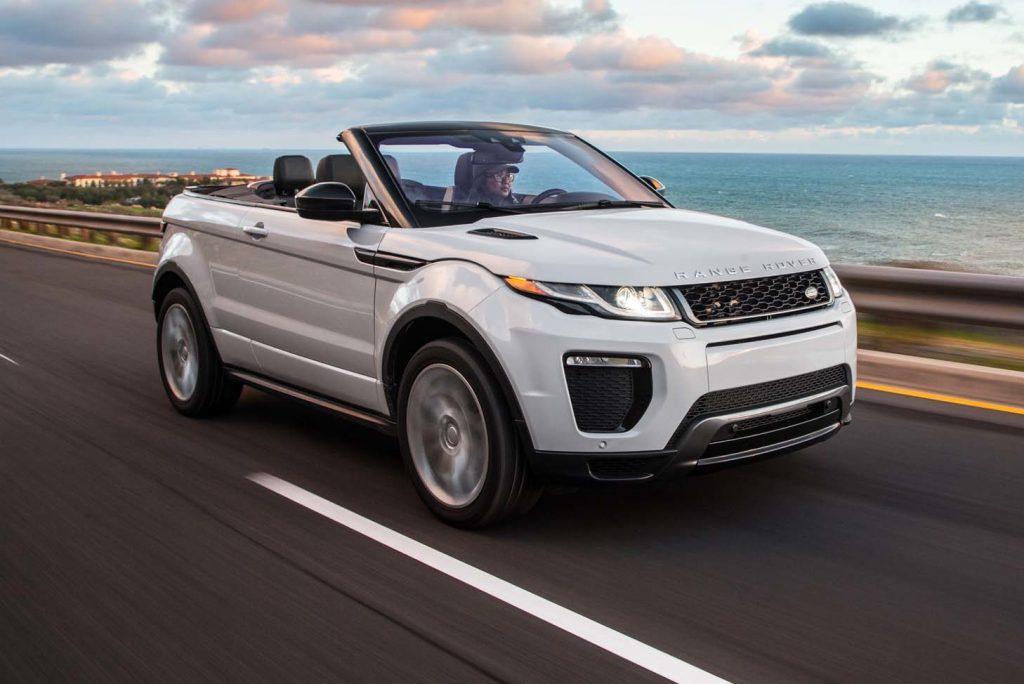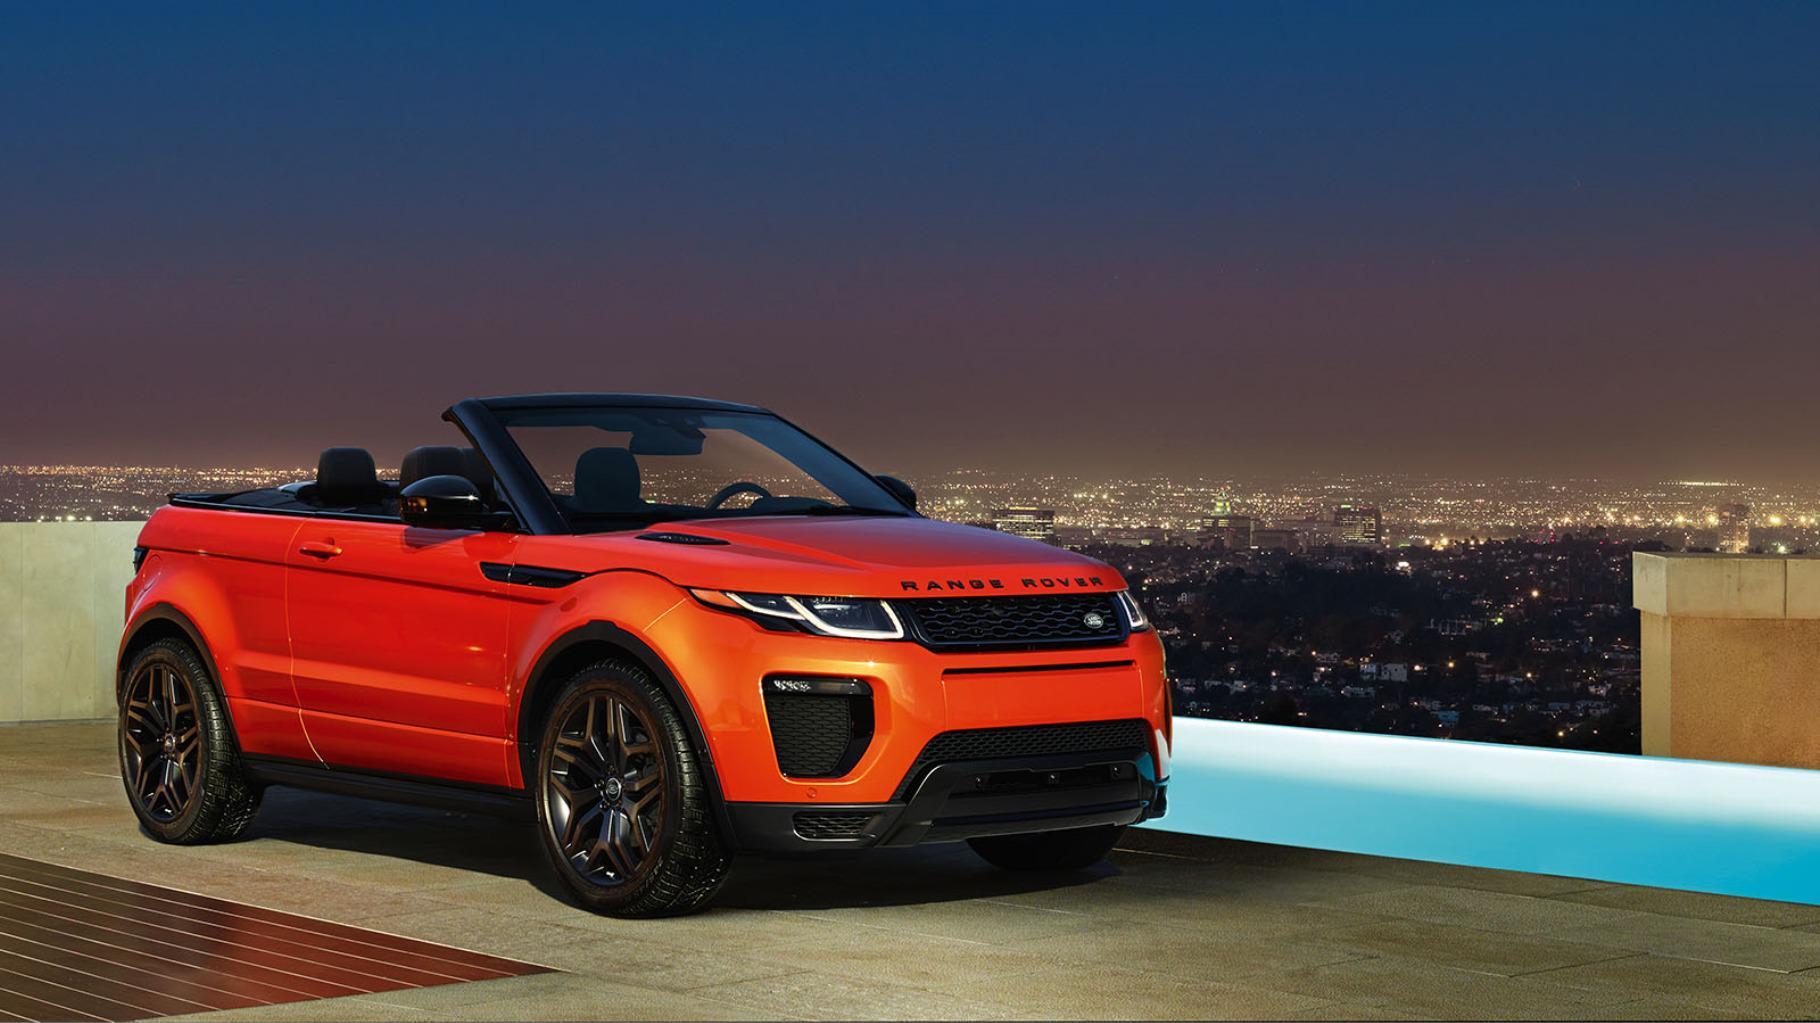The first image is the image on the left, the second image is the image on the right. Given the left and right images, does the statement "There is one orange convertible with the top down and one white convertible with the top down" hold true? Answer yes or no. Yes. The first image is the image on the left, the second image is the image on the right. Examine the images to the left and right. Is the description "An image shows an orange convertible, which has its top down." accurate? Answer yes or no. Yes. 